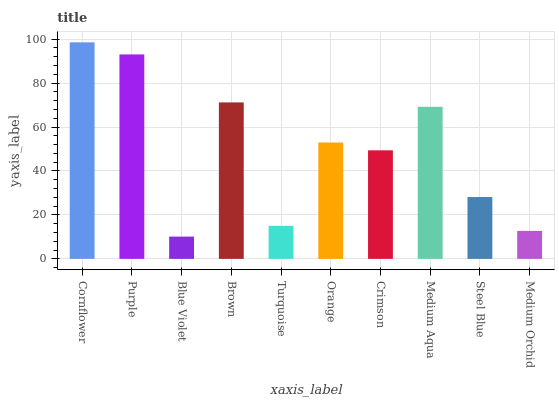Is Purple the minimum?
Answer yes or no. No. Is Purple the maximum?
Answer yes or no. No. Is Cornflower greater than Purple?
Answer yes or no. Yes. Is Purple less than Cornflower?
Answer yes or no. Yes. Is Purple greater than Cornflower?
Answer yes or no. No. Is Cornflower less than Purple?
Answer yes or no. No. Is Orange the high median?
Answer yes or no. Yes. Is Crimson the low median?
Answer yes or no. Yes. Is Medium Aqua the high median?
Answer yes or no. No. Is Medium Aqua the low median?
Answer yes or no. No. 